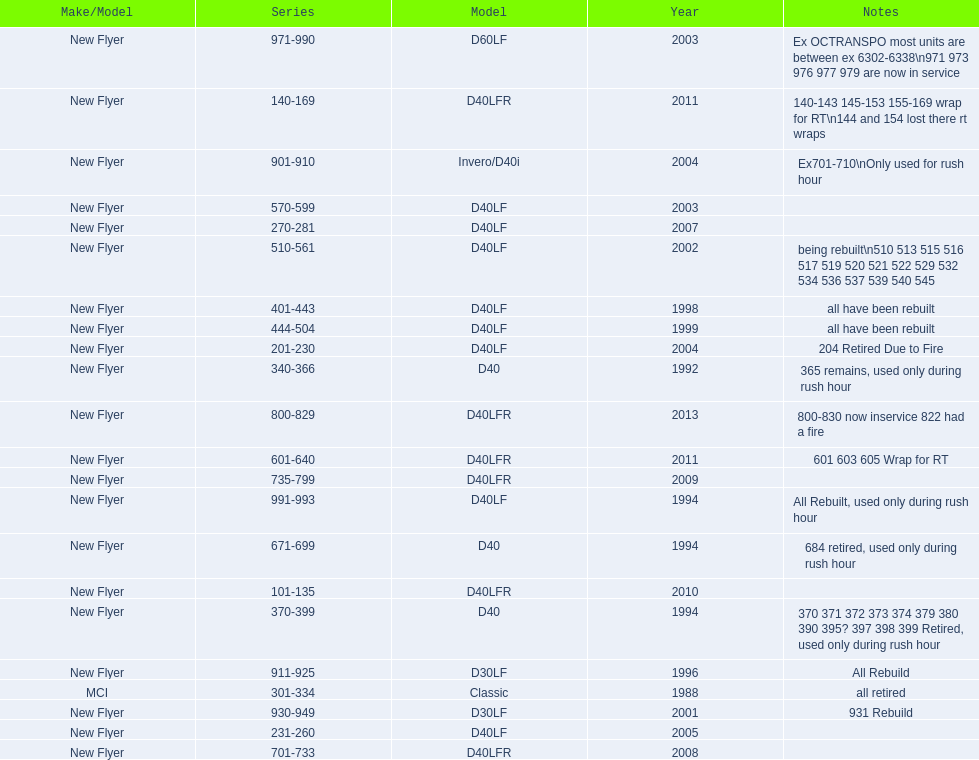What are all of the bus series numbers? 101-135, 140-169, 201-230, 231-260, 270-281, 301-334, 340-366, 370-399, 401-443, 444-504, 510-561, 570-599, 601-640, 671-699, 701-733, 735-799, 800-829, 901-910, 911-925, 930-949, 971-990, 991-993. When were they introduced? 2010, 2011, 2004, 2005, 2007, 1988, 1992, 1994, 1998, 1999, 2002, 2003, 2011, 1994, 2008, 2009, 2013, 2004, 1996, 2001, 2003, 1994. Which series is the newest? 800-829. 